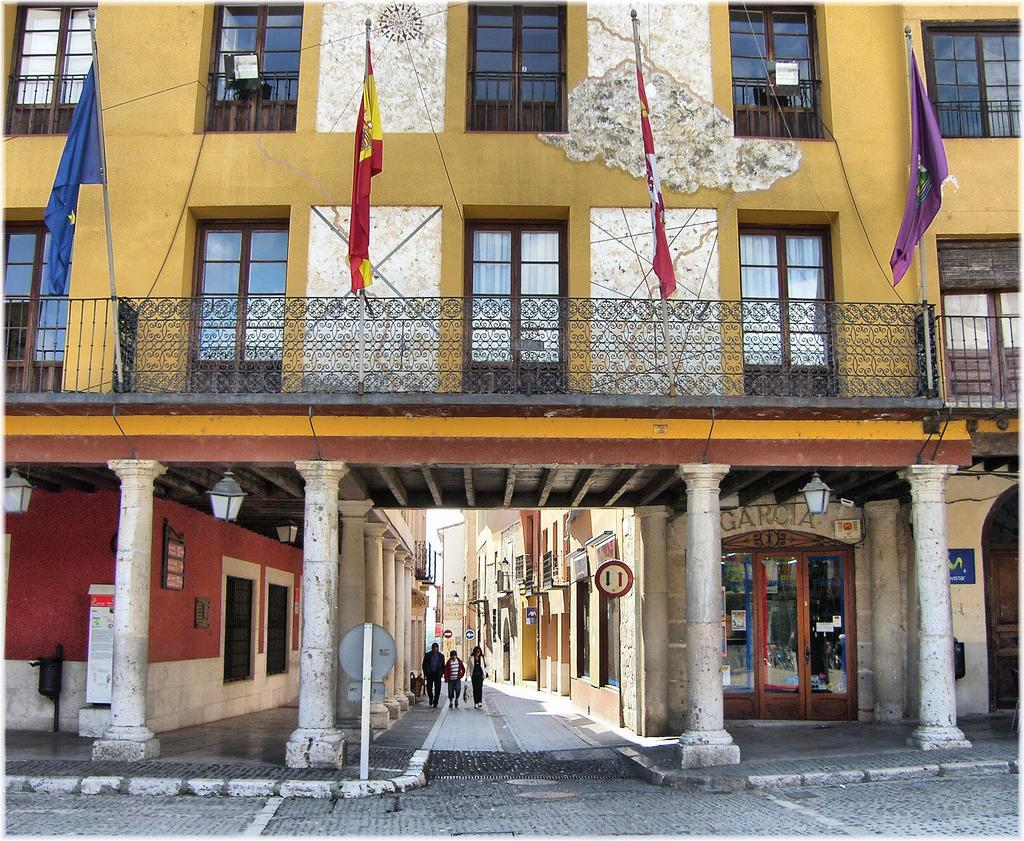What type of structures can be seen in the image? There are buildings in the image. What are the people in the image doing? People are walking on the ground in the image. What kind of information might be conveyed by the sign board in the image? The sign board in the image might convey information about directions, advertisements, or notices. What type of visuals are present in the image? Posters and flags are visible in the image. What type of lighting is present in the image? Lanterns are visible in the image. What type of barrier is present in the image? There is a fence in the image. What type of architectural elements are present in the image? Pillars are present in the image. How many ants are crawling on the sign board in the image? There are no ants present on the sign board in the image. What letter is written on the poster in the image? There is no specific letter mentioned in the provided facts, and the poster is not described in detail. 